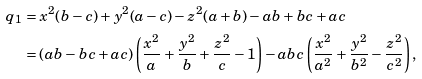Convert formula to latex. <formula><loc_0><loc_0><loc_500><loc_500>q _ { 1 } & = x ^ { 2 } ( b - c ) + y ^ { 2 } ( a - c ) - z ^ { 2 } ( a + b ) - a b + b c + a c \\ & = ( a b - b c + a c ) \left ( \frac { x ^ { 2 } } { a } + \frac { y ^ { 2 } } { b } + \frac { z ^ { 2 } } { c } - 1 \right ) - a b c \left ( \frac { x ^ { 2 } } { a ^ { 2 } } + \frac { y ^ { 2 } } { b ^ { 2 } } - \frac { z ^ { 2 } } { c ^ { 2 } } \right ) ,</formula> 